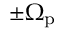<formula> <loc_0><loc_0><loc_500><loc_500>\pm \Omega _ { p }</formula> 